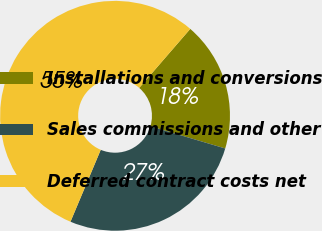<chart> <loc_0><loc_0><loc_500><loc_500><pie_chart><fcel>Installations and conversions<fcel>Sales commissions and other<fcel>Deferred contract costs net<nl><fcel>18.24%<fcel>26.75%<fcel>55.02%<nl></chart> 